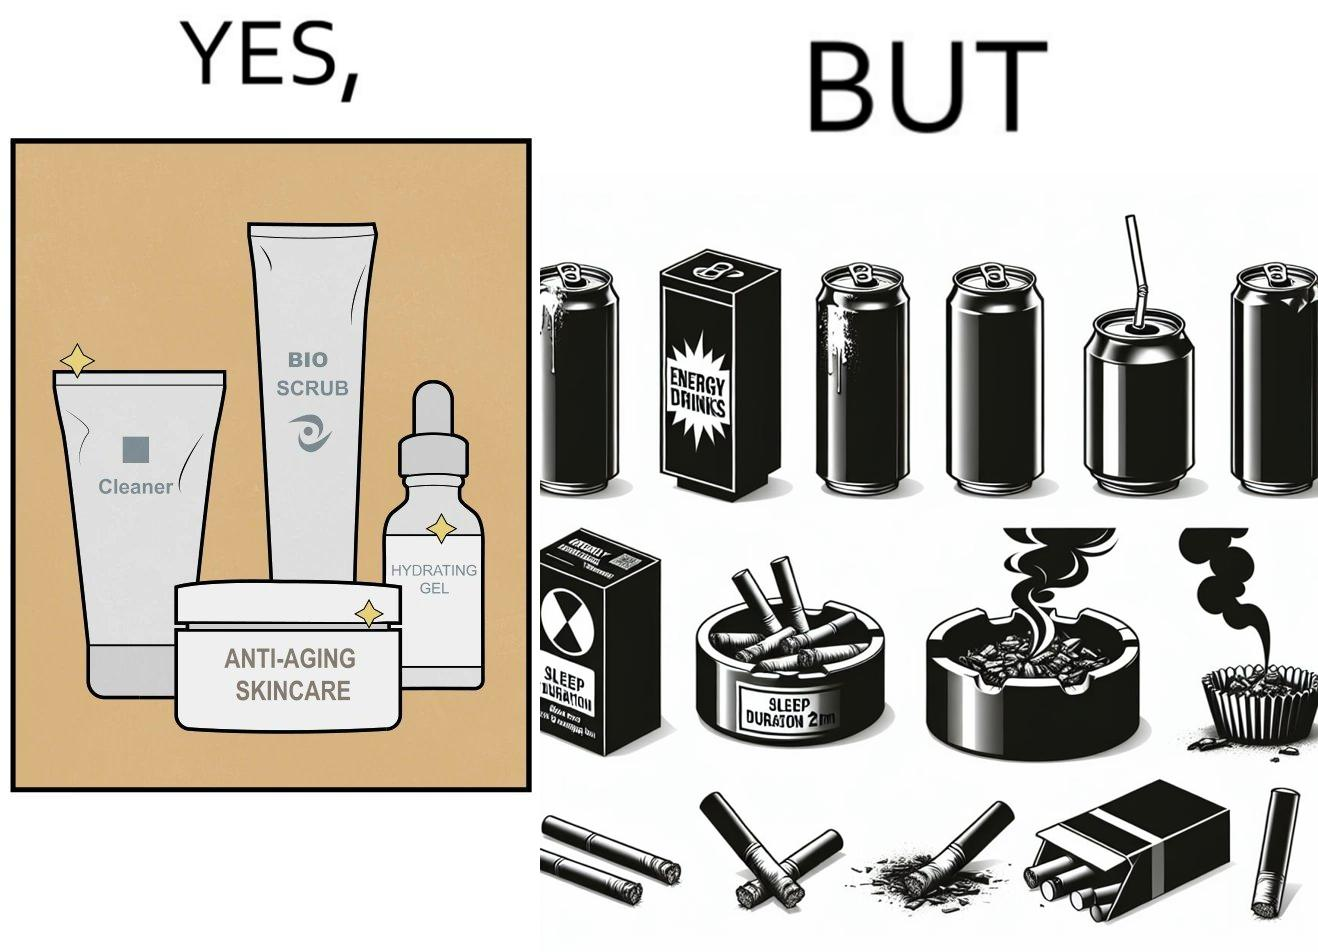Compare the left and right sides of this image. In the left part of the image: 4 Skincare products, arranged aesthetically. A tube labeled "Cleaner". A tube labeled "BIO SCRUB". A dropper bottle labeled "HYDRATING GEL". A jar called "ANTI-AGING SKINCARE". In the right part of the image: 9 cans of red bull, some standing upright, some crushed. Cans have blue and red colors. An ashtray with many cigarette butts in it and has smoke coming out. A banner that says "Sleep duration 2h 5min". 